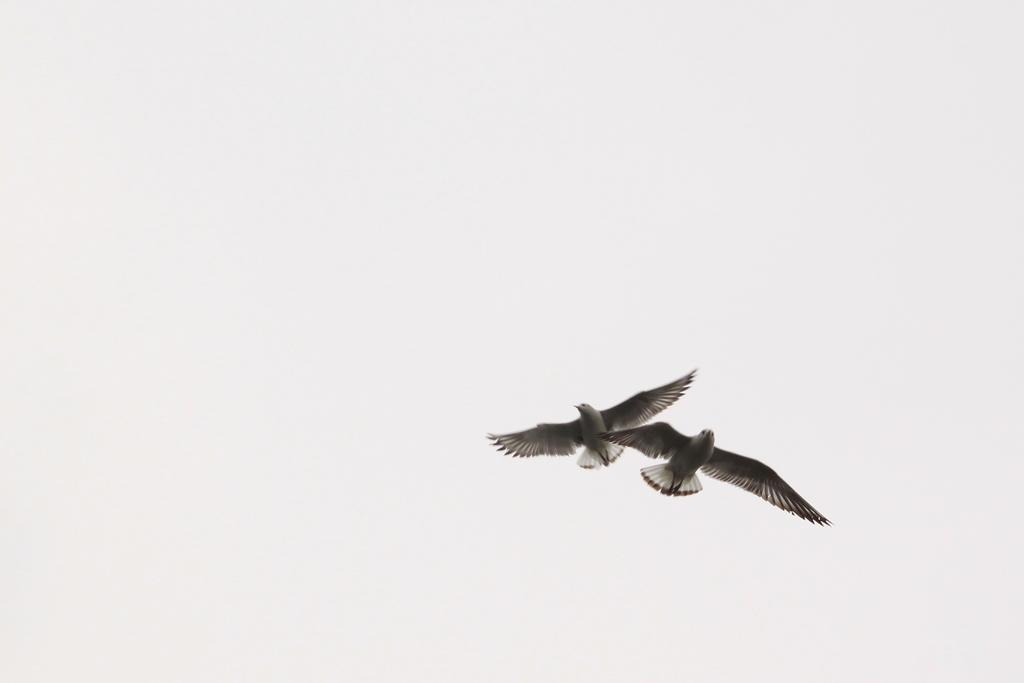What is happening in the image? There are two birds flying in the image. What can be seen in the background of the image? The background of the image is white. Can you see any dinosaurs in the image? No, there are no dinosaurs present in the image. 